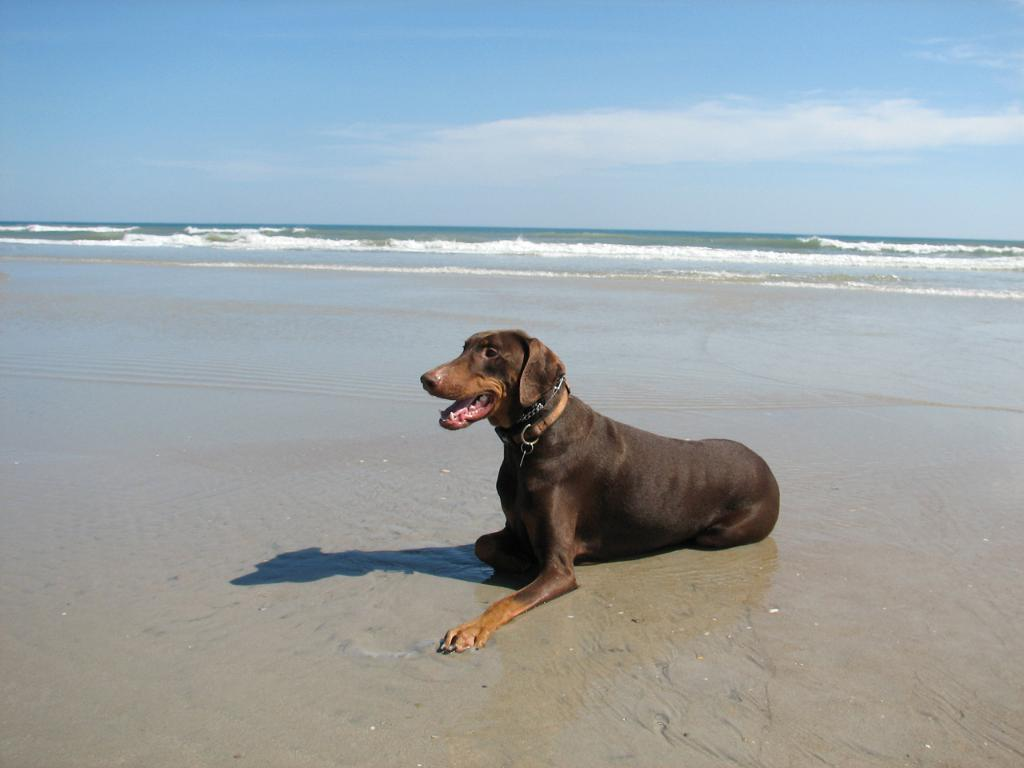What type of animal is in the image? There is a dog in the image. What natural feature can be seen in the image? There is a river in the image. What part of the natural environment is visible in the image? The sky is visible in the image. What type of lunchroom can be seen in the image? There is no lunchroom present in the image. What taste is associated with the dog in the image? The image does not convey any taste information, as it is a visual representation. 